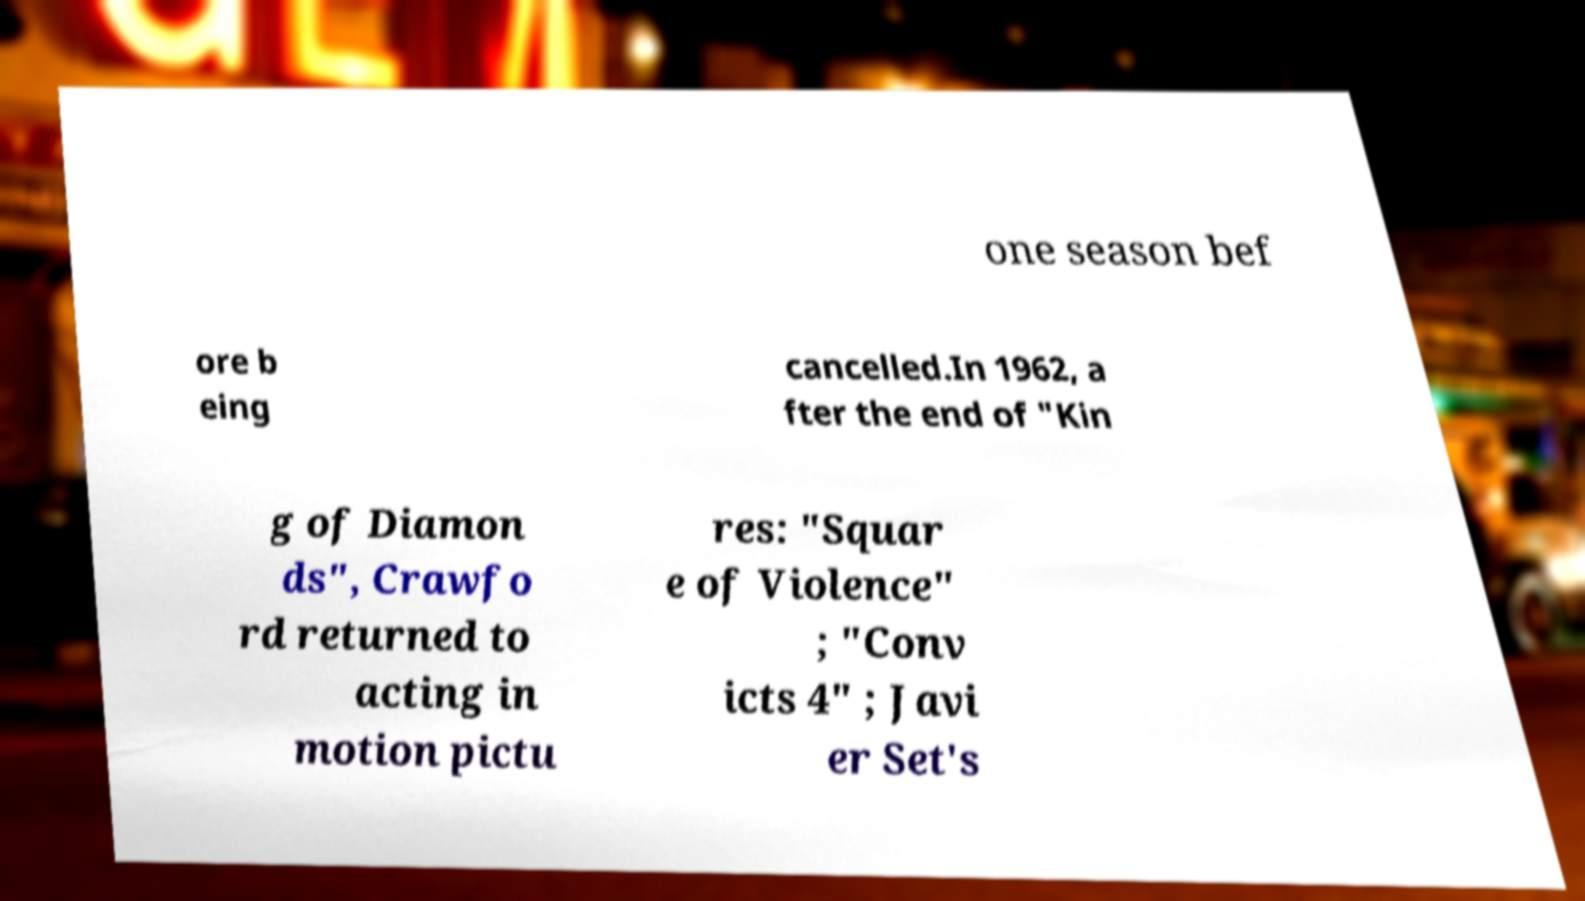Please read and relay the text visible in this image. What does it say? one season bef ore b eing cancelled.In 1962, a fter the end of "Kin g of Diamon ds", Crawfo rd returned to acting in motion pictu res: "Squar e of Violence" ; "Conv icts 4" ; Javi er Set's 